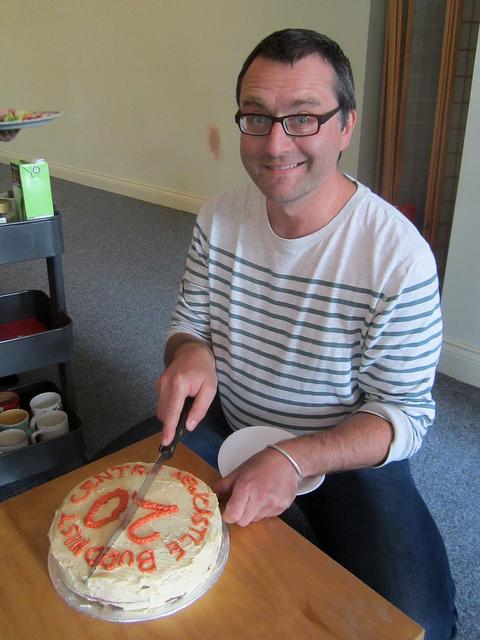What is the drawing on the cake?
Keep it brief. 20. Is he using a pizza cutter?
Short answer required. No. Is the cake vanilla?
Be succinct. Yes. What is the guy holding?
Give a very brief answer. Knife. What is the cake celebrating?
Concise answer only. Birthday. What is written on the cake?
Write a very short answer. 20. What is the cake covered in?
Concise answer only. Frosting. What is in the picture?
Answer briefly. Cake. Is the man wearing glasses?
Give a very brief answer. Yes. What kind of food is this?
Quick response, please. Cake. What is the man holding the cake with?
Quick response, please. Hand. What utensils is the man using?
Be succinct. Knife. What's on the plate?
Quick response, please. Cake. What holiday season is it?
Write a very short answer. Birthday. What event is being celebrated?
Keep it brief. Birthday. Who is the woman in the photo?
Be succinct. No woman. What fruit is on the cake?
Concise answer only. None. What is the man eating?
Answer briefly. Cake. How many slices are taken out of the cake?
Be succinct. 0. Are there stripes on his shirt?
Concise answer only. Yes. What is the number on the cake?
Short answer required. 20. How many people are in the picture?
Be succinct. 1. 